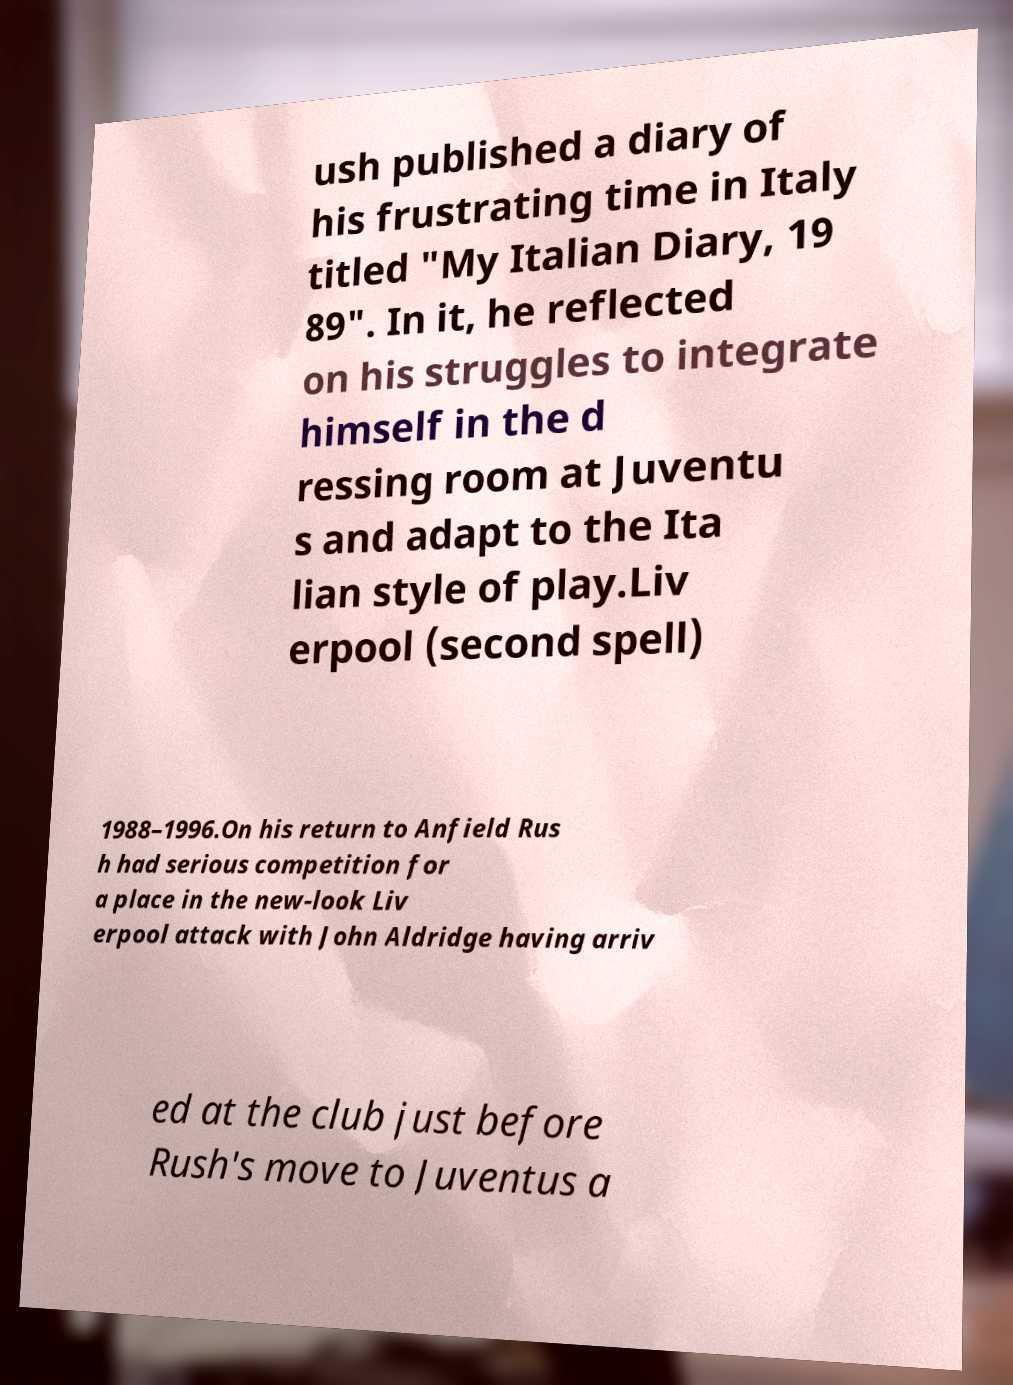There's text embedded in this image that I need extracted. Can you transcribe it verbatim? ush published a diary of his frustrating time in Italy titled "My Italian Diary, 19 89". In it, he reflected on his struggles to integrate himself in the d ressing room at Juventu s and adapt to the Ita lian style of play.Liv erpool (second spell) 1988–1996.On his return to Anfield Rus h had serious competition for a place in the new-look Liv erpool attack with John Aldridge having arriv ed at the club just before Rush's move to Juventus a 